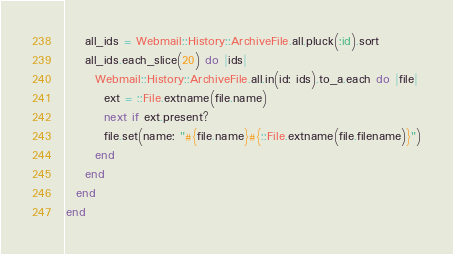<code> <loc_0><loc_0><loc_500><loc_500><_Ruby_>    all_ids = Webmail::History::ArchiveFile.all.pluck(:id).sort
    all_ids.each_slice(20) do |ids|
      Webmail::History::ArchiveFile.all.in(id: ids).to_a.each do |file|
        ext = ::File.extname(file.name)
        next if ext.present?
        file.set(name: "#{file.name}#{::File.extname(file.filename)}")
      end
    end
  end
end
</code> 